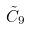Convert formula to latex. <formula><loc_0><loc_0><loc_500><loc_500>\tilde { C } _ { 9 }</formula> 